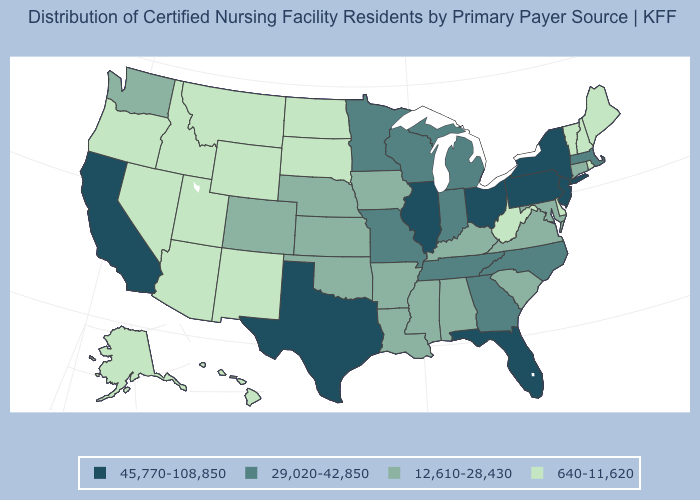Does Oklahoma have a lower value than Georgia?
Be succinct. Yes. What is the value of West Virginia?
Answer briefly. 640-11,620. Is the legend a continuous bar?
Short answer required. No. Does the first symbol in the legend represent the smallest category?
Short answer required. No. Name the states that have a value in the range 640-11,620?
Answer briefly. Alaska, Arizona, Delaware, Hawaii, Idaho, Maine, Montana, Nevada, New Hampshire, New Mexico, North Dakota, Oregon, Rhode Island, South Dakota, Utah, Vermont, West Virginia, Wyoming. What is the lowest value in states that border New Hampshire?
Answer briefly. 640-11,620. Name the states that have a value in the range 45,770-108,850?
Short answer required. California, Florida, Illinois, New Jersey, New York, Ohio, Pennsylvania, Texas. Name the states that have a value in the range 45,770-108,850?
Write a very short answer. California, Florida, Illinois, New Jersey, New York, Ohio, Pennsylvania, Texas. What is the value of Missouri?
Be succinct. 29,020-42,850. Does Pennsylvania have the lowest value in the Northeast?
Concise answer only. No. Name the states that have a value in the range 640-11,620?
Write a very short answer. Alaska, Arizona, Delaware, Hawaii, Idaho, Maine, Montana, Nevada, New Hampshire, New Mexico, North Dakota, Oregon, Rhode Island, South Dakota, Utah, Vermont, West Virginia, Wyoming. What is the value of Tennessee?
Concise answer only. 29,020-42,850. Name the states that have a value in the range 12,610-28,430?
Short answer required. Alabama, Arkansas, Colorado, Connecticut, Iowa, Kansas, Kentucky, Louisiana, Maryland, Mississippi, Nebraska, Oklahoma, South Carolina, Virginia, Washington. Which states hav the highest value in the Northeast?
Keep it brief. New Jersey, New York, Pennsylvania. Name the states that have a value in the range 640-11,620?
Write a very short answer. Alaska, Arizona, Delaware, Hawaii, Idaho, Maine, Montana, Nevada, New Hampshire, New Mexico, North Dakota, Oregon, Rhode Island, South Dakota, Utah, Vermont, West Virginia, Wyoming. 